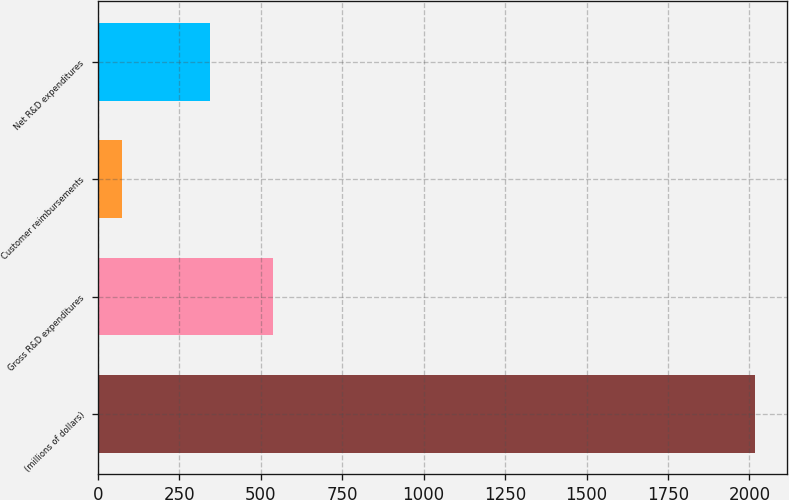<chart> <loc_0><loc_0><loc_500><loc_500><bar_chart><fcel>(millions of dollars)<fcel>Gross R&D expenditures<fcel>Customer reimbursements<fcel>Net R&D expenditures<nl><fcel>2016<fcel>537.34<fcel>74.6<fcel>343.2<nl></chart> 